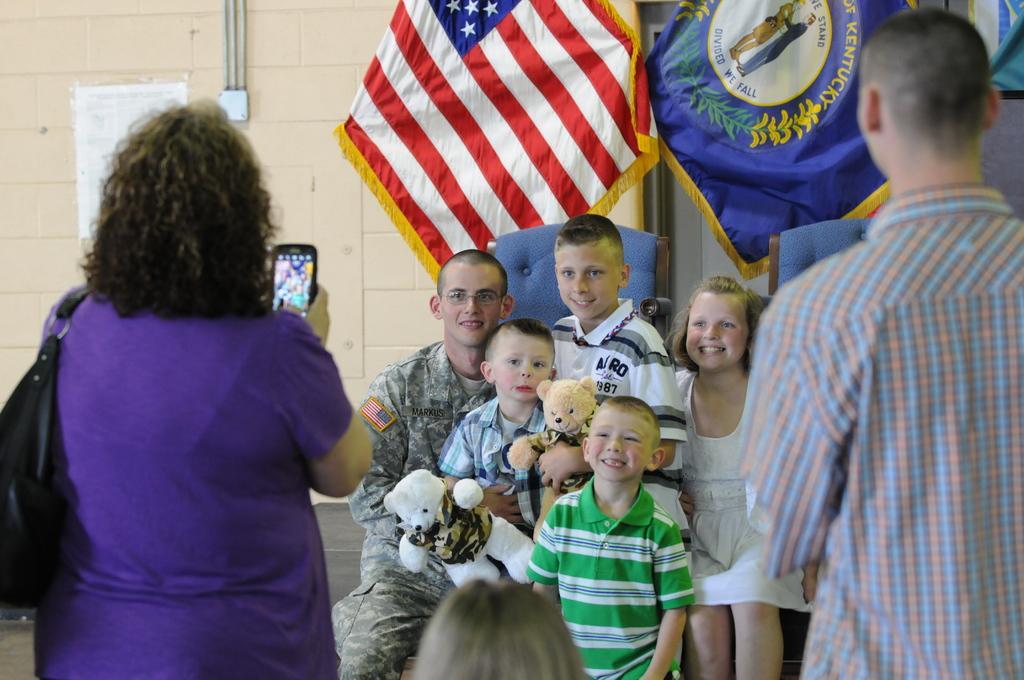Please provide a concise description of this image. In this picture there are five persons where two among them are holding a doll in their hands and there are two persons standing in front of them and the woman wearing violet dress is holding a camera in her hand and there are two flags in the background. 